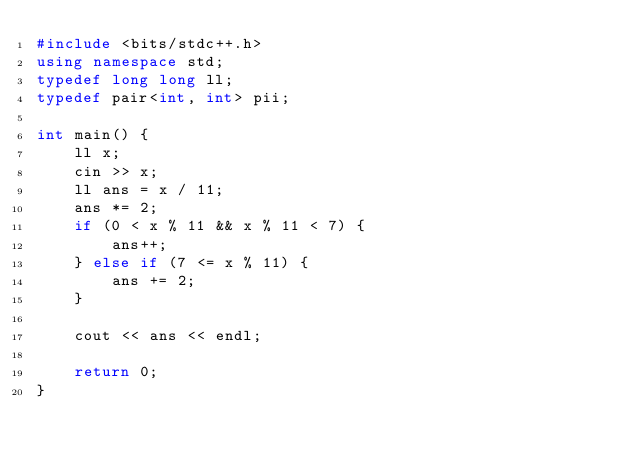Convert code to text. <code><loc_0><loc_0><loc_500><loc_500><_C++_>#include <bits/stdc++.h>
using namespace std;
typedef long long ll;
typedef pair<int, int> pii;

int main() {
    ll x;
    cin >> x;
    ll ans = x / 11;
    ans *= 2;
    if (0 < x % 11 && x % 11 < 7) {
        ans++;
    } else if (7 <= x % 11) {
        ans += 2;
    }

    cout << ans << endl;

    return 0;
}
</code> 